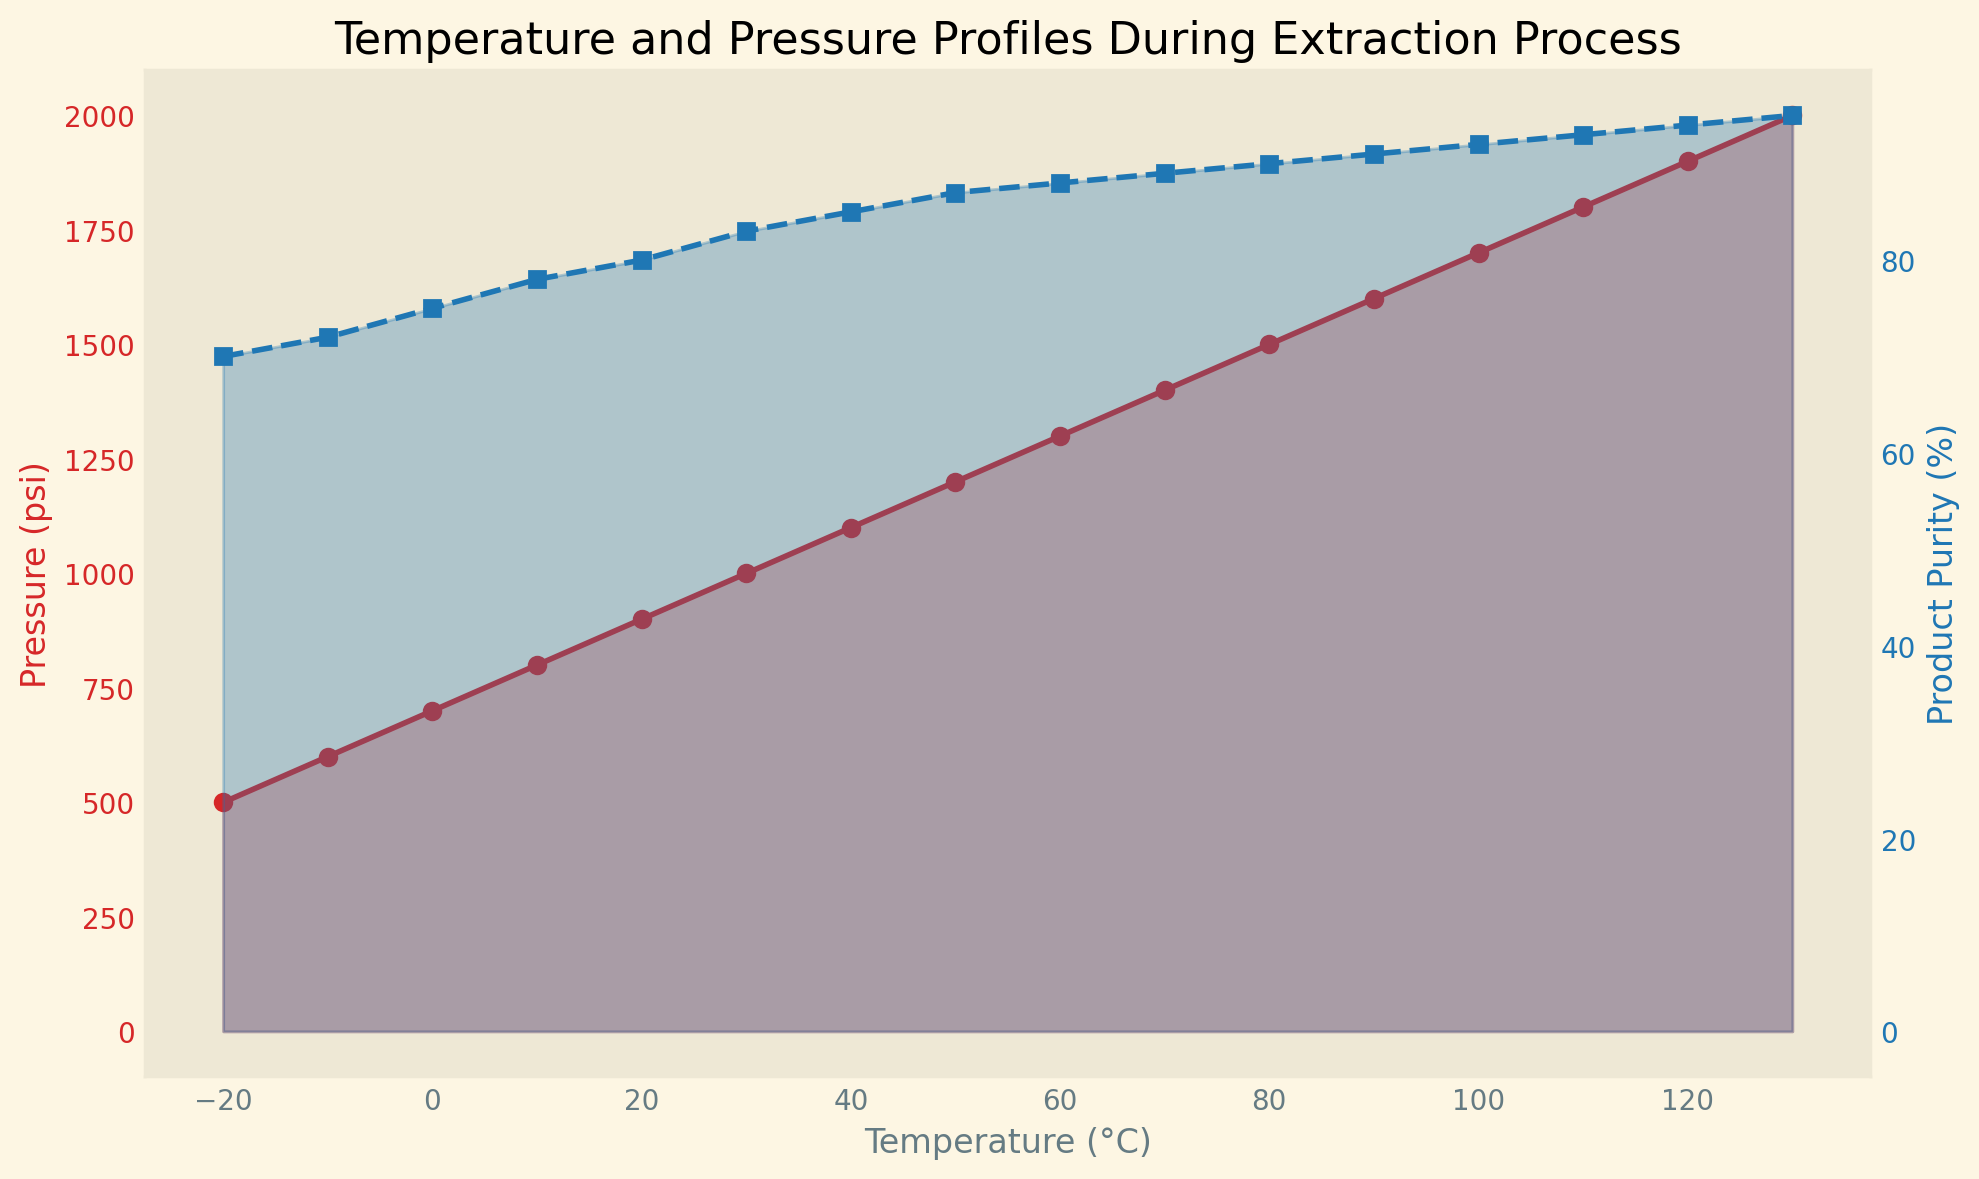What is the highest product purity achieved in the chart? To find the highest product purity, we look at the peak value on the secondary y-axis (Product Purity %). The maximum value observed is 95%.
Answer: 95% What is the temperature when the pressure reaches 1000 psi? To determine the temperature corresponding to a pressure of 1000 psi, find where the primary y-axis (Pressure (psi)) intersects with 1000 on the x-axis (Temperature). The temperature is 30°C.
Answer: 30°C How does product purity change from 50°C to 90°C? To evaluate the change in product purity between these temperatures, look at the values at 50°C (87%) and 90°C (91%) on the secondary y-axis. Subtract the initial value from the final value (91% - 87%). The change is 4%.
Answer: 4% At which temperature do both pressure and product purity show a marked increase? Observing the trends, both pressure and purity increase steeply around the 0°C mark. Pressure rises from 600 to 1000 psi, and purity increases from 72% to 83%.
Answer: 0°C and around Calculate the average product purity between temperatures of 20°C and 80°C. First, note the product purity values at 20°C (80%), 30°C (83%), 40°C (85%), 50°C (87%), 60°C (88%), and 70°C (89%), and 80°C (90%). Then, find the average: (80 + 83 + 85 + 87 + 88 + 89 + 90) / 7. The average is 86%.
Answer: 86% At what psi does product purity reach 90%? Locate where the product purity curve hits 90% on the secondary y-axis. This corresponds to a primary y-axis (Pressure (psi)) value of 1500 psi.
Answer: 1500 psi How much does pressure increase per 10°C increase in temperature? Divide the total pressure increase by the temperature range. The pressure rises from -20°C (500 psi) to 130°C (2000 psi), a total increase of 1500 psi over 150°C. Thus, 1500 psi / 150°C equals 10 psi/°C.
Answer: 10 psi per 10°C At which temperature do both pressure and product purity seem to change the least? Identify where both rate of change curves flatten out the most. Between 80°C (1500 psi and 90%) and 90°C (1600 psi and 91%), the increase is minimal.
Answer: 80°C Compare the rate of change in pressure between -20°C to 0°C and 100°C to 120°C. Which interval has a higher rate of change? Between -20°C to 0°C, pressure changes from 500 psi to 700 psi (a 200 psi increase over 20°C). Between 100°C to 120°C, pressure changes from 1700 psi to 1900 psi (also a 200 psi increase over 20°C). The rates are the same.
Answer: Both intervals have the same rate of change When pressure is at 900 psi, what is the corresponding product purity? Locate where 900 psi intersects on the primary y-axis (Pressure) and reference the secondary y-axis for product purity. The corresponding product purity is 80%.
Answer: 80% 